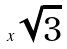<formula> <loc_0><loc_0><loc_500><loc_500>x \sqrt { 3 }</formula> 